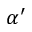Convert formula to latex. <formula><loc_0><loc_0><loc_500><loc_500>\alpha ^ { \prime }</formula> 